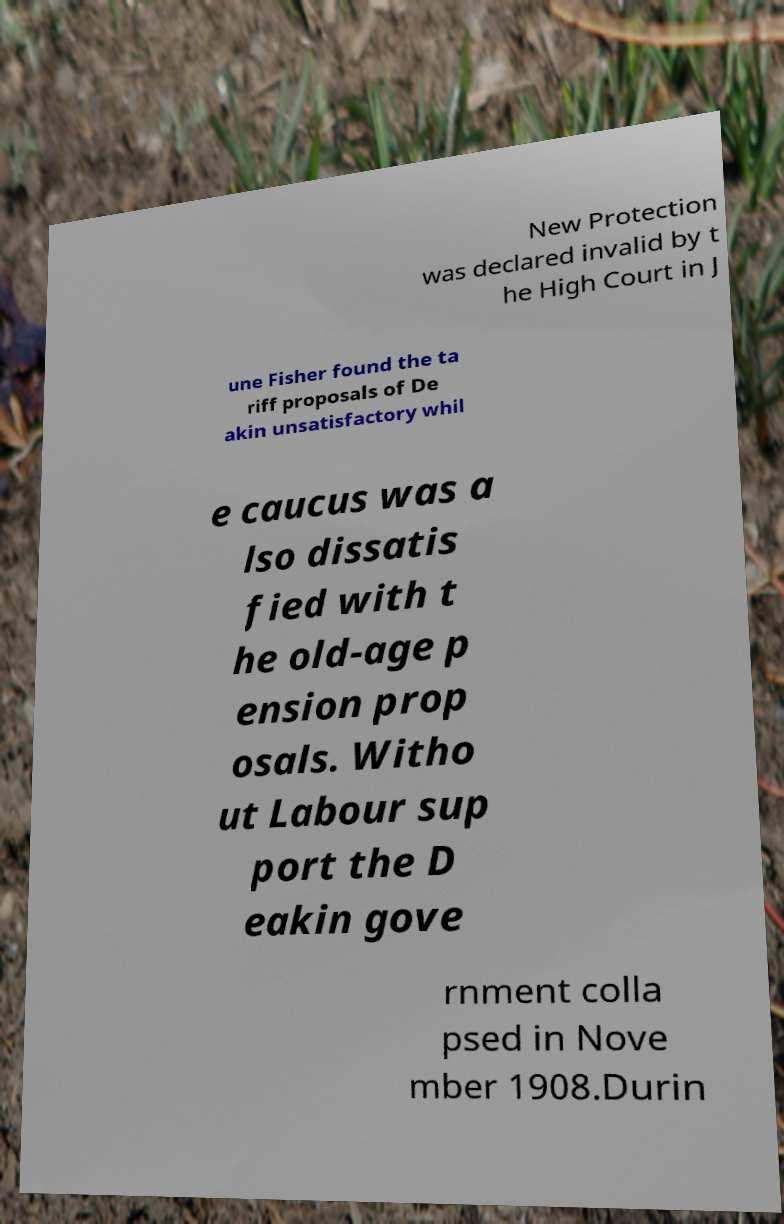Please read and relay the text visible in this image. What does it say? New Protection was declared invalid by t he High Court in J une Fisher found the ta riff proposals of De akin unsatisfactory whil e caucus was a lso dissatis fied with t he old-age p ension prop osals. Witho ut Labour sup port the D eakin gove rnment colla psed in Nove mber 1908.Durin 